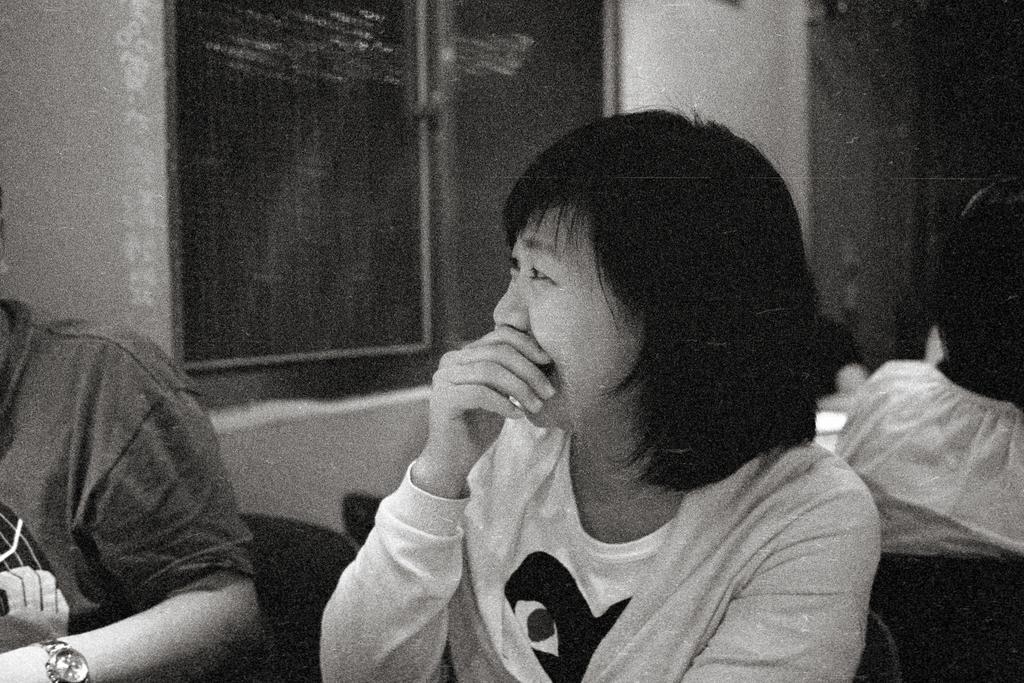Please provide a concise description of this image. In this image I can see two persons. There is a wall with window and in the background there are few people. 